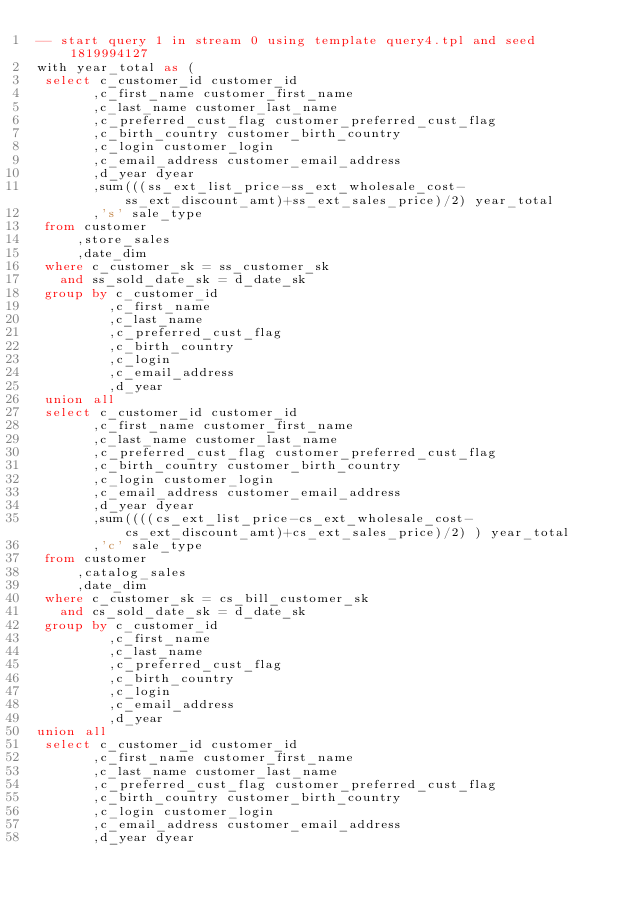Convert code to text. <code><loc_0><loc_0><loc_500><loc_500><_SQL_>-- start query 1 in stream 0 using template query4.tpl and seed 1819994127
with year_total as (
 select c_customer_id customer_id
       ,c_first_name customer_first_name
       ,c_last_name customer_last_name
       ,c_preferred_cust_flag customer_preferred_cust_flag
       ,c_birth_country customer_birth_country
       ,c_login customer_login
       ,c_email_address customer_email_address
       ,d_year dyear
       ,sum(((ss_ext_list_price-ss_ext_wholesale_cost-ss_ext_discount_amt)+ss_ext_sales_price)/2) year_total
       ,'s' sale_type
 from customer
     ,store_sales
     ,date_dim
 where c_customer_sk = ss_customer_sk
   and ss_sold_date_sk = d_date_sk
 group by c_customer_id
         ,c_first_name
         ,c_last_name
         ,c_preferred_cust_flag
         ,c_birth_country
         ,c_login
         ,c_email_address
         ,d_year
 union all
 select c_customer_id customer_id
       ,c_first_name customer_first_name
       ,c_last_name customer_last_name
       ,c_preferred_cust_flag customer_preferred_cust_flag
       ,c_birth_country customer_birth_country
       ,c_login customer_login
       ,c_email_address customer_email_address
       ,d_year dyear
       ,sum((((cs_ext_list_price-cs_ext_wholesale_cost-cs_ext_discount_amt)+cs_ext_sales_price)/2) ) year_total
       ,'c' sale_type
 from customer
     ,catalog_sales
     ,date_dim
 where c_customer_sk = cs_bill_customer_sk
   and cs_sold_date_sk = d_date_sk
 group by c_customer_id
         ,c_first_name
         ,c_last_name
         ,c_preferred_cust_flag
         ,c_birth_country
         ,c_login
         ,c_email_address
         ,d_year
union all
 select c_customer_id customer_id
       ,c_first_name customer_first_name
       ,c_last_name customer_last_name
       ,c_preferred_cust_flag customer_preferred_cust_flag
       ,c_birth_country customer_birth_country
       ,c_login customer_login
       ,c_email_address customer_email_address
       ,d_year dyear</code> 